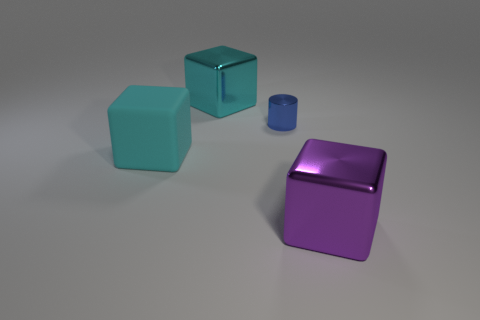Add 2 cyan things. How many objects exist? 6 Subtract all cubes. How many objects are left? 1 Add 3 small blue objects. How many small blue objects exist? 4 Subtract 0 brown balls. How many objects are left? 4 Subtract all gray shiny objects. Subtract all small things. How many objects are left? 3 Add 1 large cyan shiny blocks. How many large cyan shiny blocks are left? 2 